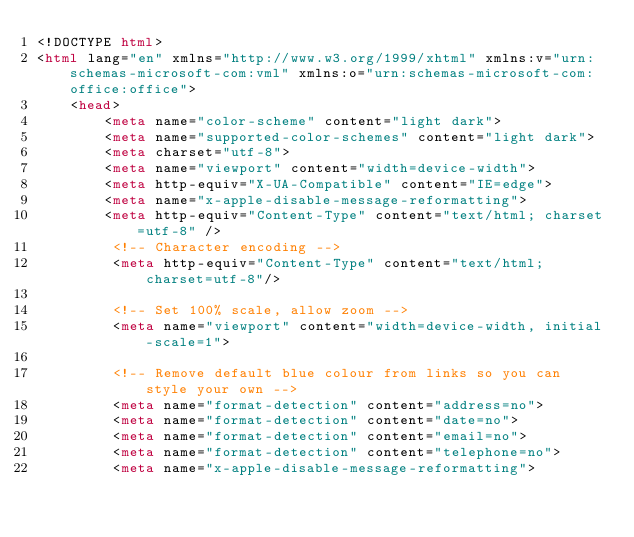<code> <loc_0><loc_0><loc_500><loc_500><_HTML_><!DOCTYPE html>
<html lang="en" xmlns="http://www.w3.org/1999/xhtml" xmlns:v="urn:schemas-microsoft-com:vml" xmlns:o="urn:schemas-microsoft-com:office:office">
    <head>
        <meta name="color-scheme" content="light dark">
        <meta name="supported-color-schemes" content="light dark">
        <meta charset="utf-8">
        <meta name="viewport" content="width=device-width">
        <meta http-equiv="X-UA-Compatible" content="IE=edge">
        <meta name="x-apple-disable-message-reformatting">
        <meta http-equiv="Content-Type" content="text/html; charset=utf-8" />
         <!-- Character encoding -->
         <meta http-equiv="Content-Type" content="text/html; charset=utf-8"/>

         <!-- Set 100% scale, allow zoom -->
         <meta name="viewport" content="width=device-width, initial-scale=1">
 
         <!-- Remove default blue colour from links so you can style your own -->
         <meta name="format-detection" content="address=no">
         <meta name="format-detection" content="date=no">
         <meta name="format-detection" content="email=no">
         <meta name="format-detection" content="telephone=no">
         <meta name="x-apple-disable-message-reformatting">
 </code> 